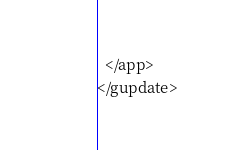<code> <loc_0><loc_0><loc_500><loc_500><_XML_>  </app>
</gupdate></code> 